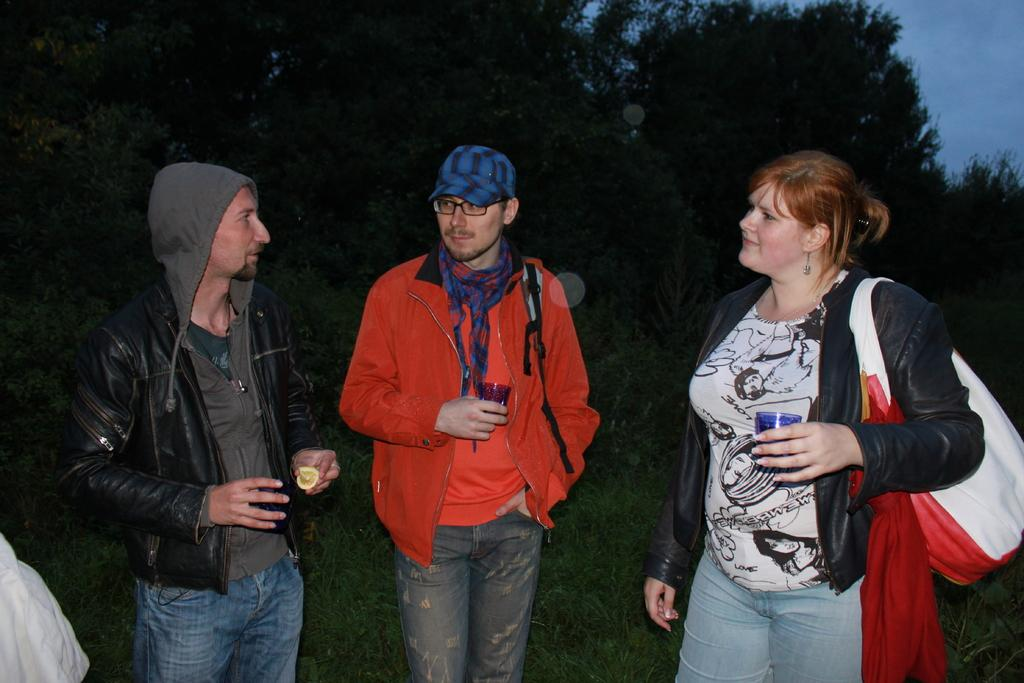What are the people in the image doing? The group of people are standing and holding objects. What can be seen in the background of the image? There are trees in the background. What is visible at the top of the image? The sky is visible at the top of the image. What type of ground is present at the bottom of the image? Grass is present at the bottom of the image. What type of market is visible in the image? There is no market present in the image. Can you provide an example of an object being held by one of the people in the image? It is not possible to provide an example of an object being held by one of the people in the image, as the specific objects they are holding are not mentioned in the provided facts. 